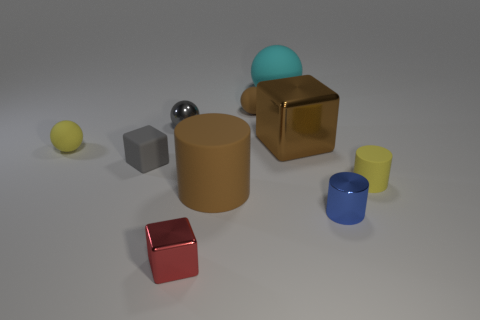Subtract 2 spheres. How many spheres are left? 2 Subtract all rubber blocks. How many blocks are left? 2 Subtract all cyan balls. How many balls are left? 3 Subtract all cubes. How many objects are left? 7 Subtract all cyan cylinders. Subtract all purple spheres. How many cylinders are left? 3 Subtract all tiny objects. Subtract all small blue shiny cylinders. How many objects are left? 2 Add 5 small brown rubber balls. How many small brown rubber balls are left? 6 Add 5 large objects. How many large objects exist? 8 Subtract 0 blue blocks. How many objects are left? 10 